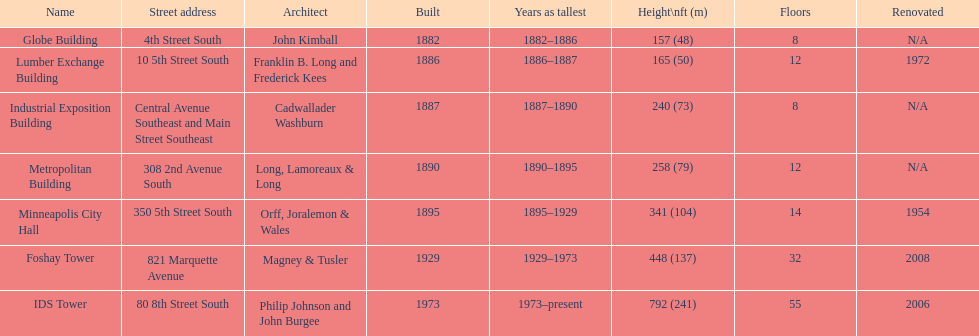What building shares the same count of floors with the lumber exchange building? Metropolitan Building. 